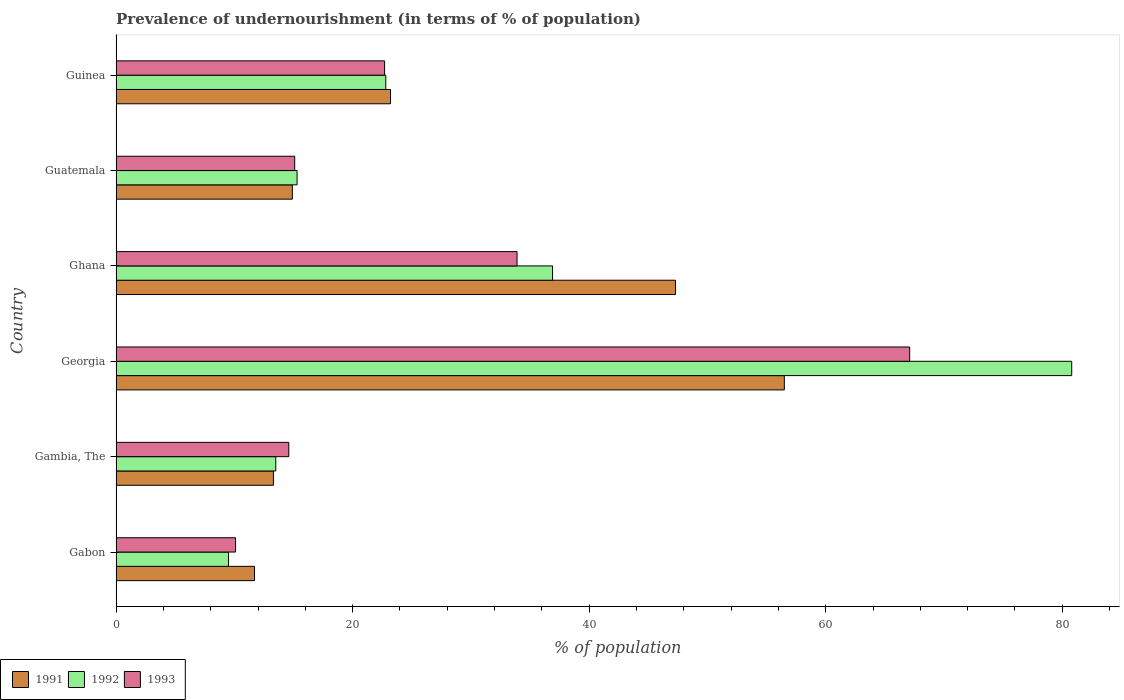How many different coloured bars are there?
Provide a succinct answer. 3. How many groups of bars are there?
Your answer should be compact. 6. How many bars are there on the 5th tick from the bottom?
Keep it short and to the point. 3. What is the label of the 5th group of bars from the top?
Provide a succinct answer. Gambia, The. Across all countries, what is the maximum percentage of undernourished population in 1993?
Provide a short and direct response. 67.1. Across all countries, what is the minimum percentage of undernourished population in 1992?
Provide a succinct answer. 9.5. In which country was the percentage of undernourished population in 1991 maximum?
Give a very brief answer. Georgia. In which country was the percentage of undernourished population in 1992 minimum?
Keep it short and to the point. Gabon. What is the total percentage of undernourished population in 1992 in the graph?
Your answer should be compact. 178.8. What is the difference between the percentage of undernourished population in 1992 in Ghana and that in Guatemala?
Provide a succinct answer. 21.6. What is the difference between the percentage of undernourished population in 1991 in Gambia, The and the percentage of undernourished population in 1993 in Guinea?
Give a very brief answer. -9.4. What is the average percentage of undernourished population in 1993 per country?
Your response must be concise. 27.25. What is the difference between the percentage of undernourished population in 1993 and percentage of undernourished population in 1991 in Ghana?
Provide a short and direct response. -13.4. What is the ratio of the percentage of undernourished population in 1993 in Gambia, The to that in Ghana?
Offer a very short reply. 0.43. Is the percentage of undernourished population in 1992 in Gabon less than that in Gambia, The?
Offer a terse response. Yes. What is the difference between the highest and the second highest percentage of undernourished population in 1991?
Provide a short and direct response. 9.2. What is the difference between the highest and the lowest percentage of undernourished population in 1991?
Your answer should be compact. 44.8. Is the sum of the percentage of undernourished population in 1991 in Georgia and Guatemala greater than the maximum percentage of undernourished population in 1993 across all countries?
Your response must be concise. Yes. What does the 2nd bar from the top in Ghana represents?
Make the answer very short. 1992. What does the 2nd bar from the bottom in Georgia represents?
Your answer should be compact. 1992. Is it the case that in every country, the sum of the percentage of undernourished population in 1993 and percentage of undernourished population in 1991 is greater than the percentage of undernourished population in 1992?
Your response must be concise. Yes. How many bars are there?
Offer a very short reply. 18. How many countries are there in the graph?
Provide a short and direct response. 6. What is the difference between two consecutive major ticks on the X-axis?
Offer a very short reply. 20. Are the values on the major ticks of X-axis written in scientific E-notation?
Make the answer very short. No. Does the graph contain grids?
Make the answer very short. No. What is the title of the graph?
Your answer should be compact. Prevalence of undernourishment (in terms of % of population). Does "1965" appear as one of the legend labels in the graph?
Your answer should be compact. No. What is the label or title of the X-axis?
Make the answer very short. % of population. What is the % of population in 1991 in Gabon?
Offer a terse response. 11.7. What is the % of population in 1991 in Gambia, The?
Offer a terse response. 13.3. What is the % of population in 1991 in Georgia?
Offer a terse response. 56.5. What is the % of population of 1992 in Georgia?
Offer a terse response. 80.8. What is the % of population of 1993 in Georgia?
Offer a very short reply. 67.1. What is the % of population in 1991 in Ghana?
Provide a short and direct response. 47.3. What is the % of population in 1992 in Ghana?
Your answer should be compact. 36.9. What is the % of population of 1993 in Ghana?
Your answer should be very brief. 33.9. What is the % of population in 1992 in Guatemala?
Your response must be concise. 15.3. What is the % of population in 1993 in Guatemala?
Your response must be concise. 15.1. What is the % of population of 1991 in Guinea?
Give a very brief answer. 23.2. What is the % of population of 1992 in Guinea?
Your answer should be compact. 22.8. What is the % of population in 1993 in Guinea?
Offer a very short reply. 22.7. Across all countries, what is the maximum % of population in 1991?
Ensure brevity in your answer.  56.5. Across all countries, what is the maximum % of population in 1992?
Keep it short and to the point. 80.8. Across all countries, what is the maximum % of population of 1993?
Give a very brief answer. 67.1. What is the total % of population of 1991 in the graph?
Offer a terse response. 166.9. What is the total % of population in 1992 in the graph?
Provide a succinct answer. 178.8. What is the total % of population of 1993 in the graph?
Offer a very short reply. 163.5. What is the difference between the % of population of 1992 in Gabon and that in Gambia, The?
Offer a terse response. -4. What is the difference between the % of population in 1993 in Gabon and that in Gambia, The?
Ensure brevity in your answer.  -4.5. What is the difference between the % of population in 1991 in Gabon and that in Georgia?
Make the answer very short. -44.8. What is the difference between the % of population in 1992 in Gabon and that in Georgia?
Your answer should be compact. -71.3. What is the difference between the % of population of 1993 in Gabon and that in Georgia?
Your answer should be very brief. -57. What is the difference between the % of population in 1991 in Gabon and that in Ghana?
Your response must be concise. -35.6. What is the difference between the % of population of 1992 in Gabon and that in Ghana?
Offer a very short reply. -27.4. What is the difference between the % of population of 1993 in Gabon and that in Ghana?
Give a very brief answer. -23.8. What is the difference between the % of population of 1991 in Gabon and that in Guatemala?
Make the answer very short. -3.2. What is the difference between the % of population in 1993 in Gabon and that in Guatemala?
Make the answer very short. -5. What is the difference between the % of population of 1991 in Gabon and that in Guinea?
Your answer should be compact. -11.5. What is the difference between the % of population in 1993 in Gabon and that in Guinea?
Your answer should be very brief. -12.6. What is the difference between the % of population in 1991 in Gambia, The and that in Georgia?
Make the answer very short. -43.2. What is the difference between the % of population of 1992 in Gambia, The and that in Georgia?
Make the answer very short. -67.3. What is the difference between the % of population of 1993 in Gambia, The and that in Georgia?
Provide a succinct answer. -52.5. What is the difference between the % of population in 1991 in Gambia, The and that in Ghana?
Offer a very short reply. -34. What is the difference between the % of population of 1992 in Gambia, The and that in Ghana?
Your answer should be compact. -23.4. What is the difference between the % of population of 1993 in Gambia, The and that in Ghana?
Your answer should be very brief. -19.3. What is the difference between the % of population in 1991 in Gambia, The and that in Guinea?
Give a very brief answer. -9.9. What is the difference between the % of population in 1993 in Gambia, The and that in Guinea?
Your response must be concise. -8.1. What is the difference between the % of population of 1992 in Georgia and that in Ghana?
Provide a short and direct response. 43.9. What is the difference between the % of population in 1993 in Georgia and that in Ghana?
Your answer should be very brief. 33.2. What is the difference between the % of population of 1991 in Georgia and that in Guatemala?
Your answer should be very brief. 41.6. What is the difference between the % of population in 1992 in Georgia and that in Guatemala?
Provide a short and direct response. 65.5. What is the difference between the % of population of 1993 in Georgia and that in Guatemala?
Ensure brevity in your answer.  52. What is the difference between the % of population of 1991 in Georgia and that in Guinea?
Give a very brief answer. 33.3. What is the difference between the % of population in 1992 in Georgia and that in Guinea?
Your response must be concise. 58. What is the difference between the % of population in 1993 in Georgia and that in Guinea?
Offer a terse response. 44.4. What is the difference between the % of population of 1991 in Ghana and that in Guatemala?
Ensure brevity in your answer.  32.4. What is the difference between the % of population of 1992 in Ghana and that in Guatemala?
Your response must be concise. 21.6. What is the difference between the % of population of 1993 in Ghana and that in Guatemala?
Ensure brevity in your answer.  18.8. What is the difference between the % of population in 1991 in Ghana and that in Guinea?
Ensure brevity in your answer.  24.1. What is the difference between the % of population of 1993 in Ghana and that in Guinea?
Give a very brief answer. 11.2. What is the difference between the % of population of 1991 in Guatemala and that in Guinea?
Offer a very short reply. -8.3. What is the difference between the % of population in 1992 in Guatemala and that in Guinea?
Your answer should be compact. -7.5. What is the difference between the % of population in 1991 in Gabon and the % of population in 1992 in Georgia?
Ensure brevity in your answer.  -69.1. What is the difference between the % of population of 1991 in Gabon and the % of population of 1993 in Georgia?
Your response must be concise. -55.4. What is the difference between the % of population of 1992 in Gabon and the % of population of 1993 in Georgia?
Your answer should be very brief. -57.6. What is the difference between the % of population in 1991 in Gabon and the % of population in 1992 in Ghana?
Offer a very short reply. -25.2. What is the difference between the % of population in 1991 in Gabon and the % of population in 1993 in Ghana?
Offer a terse response. -22.2. What is the difference between the % of population of 1992 in Gabon and the % of population of 1993 in Ghana?
Your answer should be compact. -24.4. What is the difference between the % of population in 1991 in Gabon and the % of population in 1992 in Guatemala?
Keep it short and to the point. -3.6. What is the difference between the % of population of 1991 in Gabon and the % of population of 1993 in Guinea?
Provide a succinct answer. -11. What is the difference between the % of population of 1991 in Gambia, The and the % of population of 1992 in Georgia?
Your answer should be very brief. -67.5. What is the difference between the % of population of 1991 in Gambia, The and the % of population of 1993 in Georgia?
Give a very brief answer. -53.8. What is the difference between the % of population of 1992 in Gambia, The and the % of population of 1993 in Georgia?
Offer a terse response. -53.6. What is the difference between the % of population in 1991 in Gambia, The and the % of population in 1992 in Ghana?
Provide a succinct answer. -23.6. What is the difference between the % of population of 1991 in Gambia, The and the % of population of 1993 in Ghana?
Ensure brevity in your answer.  -20.6. What is the difference between the % of population in 1992 in Gambia, The and the % of population in 1993 in Ghana?
Your answer should be compact. -20.4. What is the difference between the % of population in 1991 in Gambia, The and the % of population in 1992 in Guatemala?
Make the answer very short. -2. What is the difference between the % of population of 1991 in Gambia, The and the % of population of 1993 in Guatemala?
Give a very brief answer. -1.8. What is the difference between the % of population of 1991 in Gambia, The and the % of population of 1993 in Guinea?
Provide a succinct answer. -9.4. What is the difference between the % of population of 1991 in Georgia and the % of population of 1992 in Ghana?
Give a very brief answer. 19.6. What is the difference between the % of population in 1991 in Georgia and the % of population in 1993 in Ghana?
Give a very brief answer. 22.6. What is the difference between the % of population in 1992 in Georgia and the % of population in 1993 in Ghana?
Offer a very short reply. 46.9. What is the difference between the % of population of 1991 in Georgia and the % of population of 1992 in Guatemala?
Provide a succinct answer. 41.2. What is the difference between the % of population in 1991 in Georgia and the % of population in 1993 in Guatemala?
Provide a succinct answer. 41.4. What is the difference between the % of population of 1992 in Georgia and the % of population of 1993 in Guatemala?
Offer a terse response. 65.7. What is the difference between the % of population in 1991 in Georgia and the % of population in 1992 in Guinea?
Make the answer very short. 33.7. What is the difference between the % of population in 1991 in Georgia and the % of population in 1993 in Guinea?
Offer a very short reply. 33.8. What is the difference between the % of population in 1992 in Georgia and the % of population in 1993 in Guinea?
Your response must be concise. 58.1. What is the difference between the % of population in 1991 in Ghana and the % of population in 1993 in Guatemala?
Make the answer very short. 32.2. What is the difference between the % of population in 1992 in Ghana and the % of population in 1993 in Guatemala?
Offer a terse response. 21.8. What is the difference between the % of population of 1991 in Ghana and the % of population of 1993 in Guinea?
Offer a very short reply. 24.6. What is the difference between the % of population in 1992 in Ghana and the % of population in 1993 in Guinea?
Offer a very short reply. 14.2. What is the difference between the % of population of 1991 in Guatemala and the % of population of 1992 in Guinea?
Offer a very short reply. -7.9. What is the difference between the % of population in 1991 in Guatemala and the % of population in 1993 in Guinea?
Give a very brief answer. -7.8. What is the difference between the % of population in 1992 in Guatemala and the % of population in 1993 in Guinea?
Provide a short and direct response. -7.4. What is the average % of population in 1991 per country?
Give a very brief answer. 27.82. What is the average % of population of 1992 per country?
Keep it short and to the point. 29.8. What is the average % of population in 1993 per country?
Your response must be concise. 27.25. What is the difference between the % of population in 1991 and % of population in 1992 in Gambia, The?
Your answer should be very brief. -0.2. What is the difference between the % of population in 1991 and % of population in 1992 in Georgia?
Provide a short and direct response. -24.3. What is the difference between the % of population in 1991 and % of population in 1993 in Georgia?
Offer a very short reply. -10.6. What is the difference between the % of population of 1992 and % of population of 1993 in Georgia?
Keep it short and to the point. 13.7. What is the difference between the % of population in 1992 and % of population in 1993 in Ghana?
Make the answer very short. 3. What is the difference between the % of population in 1992 and % of population in 1993 in Guatemala?
Offer a terse response. 0.2. What is the difference between the % of population of 1991 and % of population of 1993 in Guinea?
Keep it short and to the point. 0.5. What is the difference between the % of population in 1992 and % of population in 1993 in Guinea?
Ensure brevity in your answer.  0.1. What is the ratio of the % of population of 1991 in Gabon to that in Gambia, The?
Provide a short and direct response. 0.88. What is the ratio of the % of population of 1992 in Gabon to that in Gambia, The?
Keep it short and to the point. 0.7. What is the ratio of the % of population of 1993 in Gabon to that in Gambia, The?
Make the answer very short. 0.69. What is the ratio of the % of population in 1991 in Gabon to that in Georgia?
Give a very brief answer. 0.21. What is the ratio of the % of population in 1992 in Gabon to that in Georgia?
Your answer should be very brief. 0.12. What is the ratio of the % of population of 1993 in Gabon to that in Georgia?
Keep it short and to the point. 0.15. What is the ratio of the % of population in 1991 in Gabon to that in Ghana?
Give a very brief answer. 0.25. What is the ratio of the % of population in 1992 in Gabon to that in Ghana?
Provide a short and direct response. 0.26. What is the ratio of the % of population of 1993 in Gabon to that in Ghana?
Your answer should be compact. 0.3. What is the ratio of the % of population of 1991 in Gabon to that in Guatemala?
Your answer should be very brief. 0.79. What is the ratio of the % of population of 1992 in Gabon to that in Guatemala?
Your response must be concise. 0.62. What is the ratio of the % of population of 1993 in Gabon to that in Guatemala?
Your response must be concise. 0.67. What is the ratio of the % of population of 1991 in Gabon to that in Guinea?
Provide a succinct answer. 0.5. What is the ratio of the % of population in 1992 in Gabon to that in Guinea?
Your response must be concise. 0.42. What is the ratio of the % of population of 1993 in Gabon to that in Guinea?
Your answer should be very brief. 0.44. What is the ratio of the % of population in 1991 in Gambia, The to that in Georgia?
Your response must be concise. 0.24. What is the ratio of the % of population of 1992 in Gambia, The to that in Georgia?
Offer a terse response. 0.17. What is the ratio of the % of population of 1993 in Gambia, The to that in Georgia?
Your response must be concise. 0.22. What is the ratio of the % of population in 1991 in Gambia, The to that in Ghana?
Make the answer very short. 0.28. What is the ratio of the % of population of 1992 in Gambia, The to that in Ghana?
Offer a terse response. 0.37. What is the ratio of the % of population of 1993 in Gambia, The to that in Ghana?
Provide a succinct answer. 0.43. What is the ratio of the % of population in 1991 in Gambia, The to that in Guatemala?
Provide a short and direct response. 0.89. What is the ratio of the % of population in 1992 in Gambia, The to that in Guatemala?
Make the answer very short. 0.88. What is the ratio of the % of population in 1993 in Gambia, The to that in Guatemala?
Make the answer very short. 0.97. What is the ratio of the % of population of 1991 in Gambia, The to that in Guinea?
Ensure brevity in your answer.  0.57. What is the ratio of the % of population in 1992 in Gambia, The to that in Guinea?
Offer a terse response. 0.59. What is the ratio of the % of population of 1993 in Gambia, The to that in Guinea?
Keep it short and to the point. 0.64. What is the ratio of the % of population in 1991 in Georgia to that in Ghana?
Provide a succinct answer. 1.19. What is the ratio of the % of population in 1992 in Georgia to that in Ghana?
Your answer should be very brief. 2.19. What is the ratio of the % of population in 1993 in Georgia to that in Ghana?
Offer a terse response. 1.98. What is the ratio of the % of population of 1991 in Georgia to that in Guatemala?
Offer a terse response. 3.79. What is the ratio of the % of population of 1992 in Georgia to that in Guatemala?
Offer a very short reply. 5.28. What is the ratio of the % of population in 1993 in Georgia to that in Guatemala?
Your response must be concise. 4.44. What is the ratio of the % of population in 1991 in Georgia to that in Guinea?
Offer a terse response. 2.44. What is the ratio of the % of population in 1992 in Georgia to that in Guinea?
Offer a terse response. 3.54. What is the ratio of the % of population in 1993 in Georgia to that in Guinea?
Your answer should be compact. 2.96. What is the ratio of the % of population in 1991 in Ghana to that in Guatemala?
Give a very brief answer. 3.17. What is the ratio of the % of population in 1992 in Ghana to that in Guatemala?
Offer a terse response. 2.41. What is the ratio of the % of population of 1993 in Ghana to that in Guatemala?
Ensure brevity in your answer.  2.25. What is the ratio of the % of population of 1991 in Ghana to that in Guinea?
Ensure brevity in your answer.  2.04. What is the ratio of the % of population of 1992 in Ghana to that in Guinea?
Your answer should be very brief. 1.62. What is the ratio of the % of population in 1993 in Ghana to that in Guinea?
Ensure brevity in your answer.  1.49. What is the ratio of the % of population in 1991 in Guatemala to that in Guinea?
Your response must be concise. 0.64. What is the ratio of the % of population of 1992 in Guatemala to that in Guinea?
Your answer should be very brief. 0.67. What is the ratio of the % of population in 1993 in Guatemala to that in Guinea?
Give a very brief answer. 0.67. What is the difference between the highest and the second highest % of population in 1992?
Your answer should be compact. 43.9. What is the difference between the highest and the second highest % of population of 1993?
Offer a very short reply. 33.2. What is the difference between the highest and the lowest % of population of 1991?
Your response must be concise. 44.8. What is the difference between the highest and the lowest % of population of 1992?
Your answer should be compact. 71.3. 